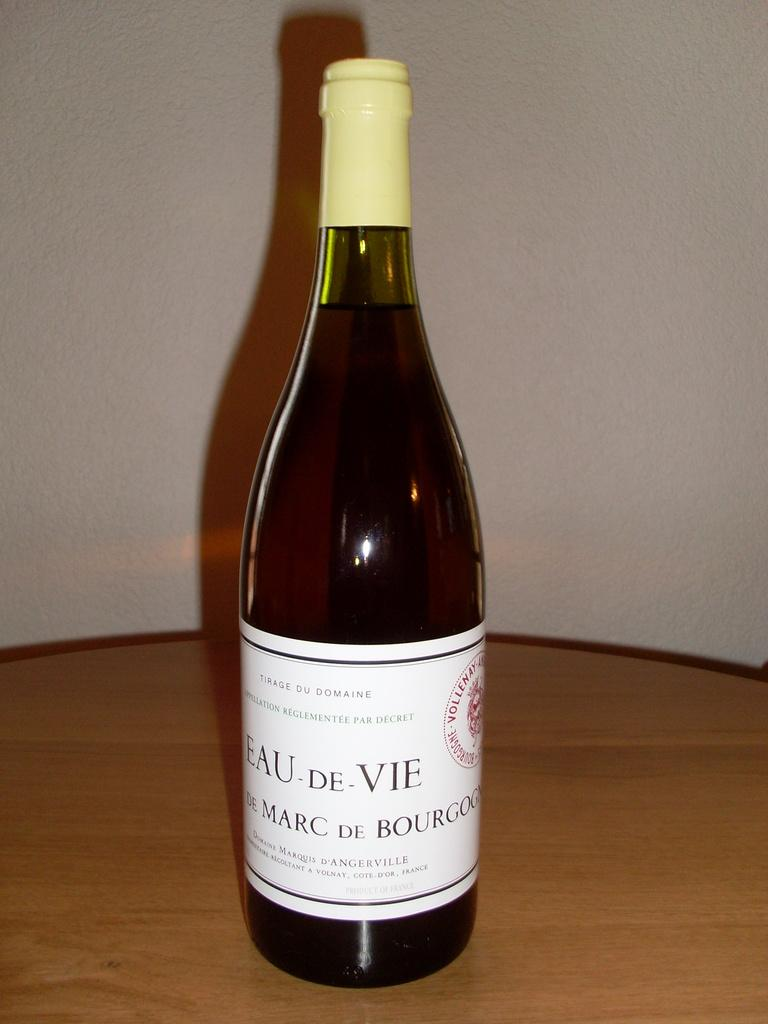<image>
Give a short and clear explanation of the subsequent image. A bottle of Eau De Vie French wine on a table unopened. 